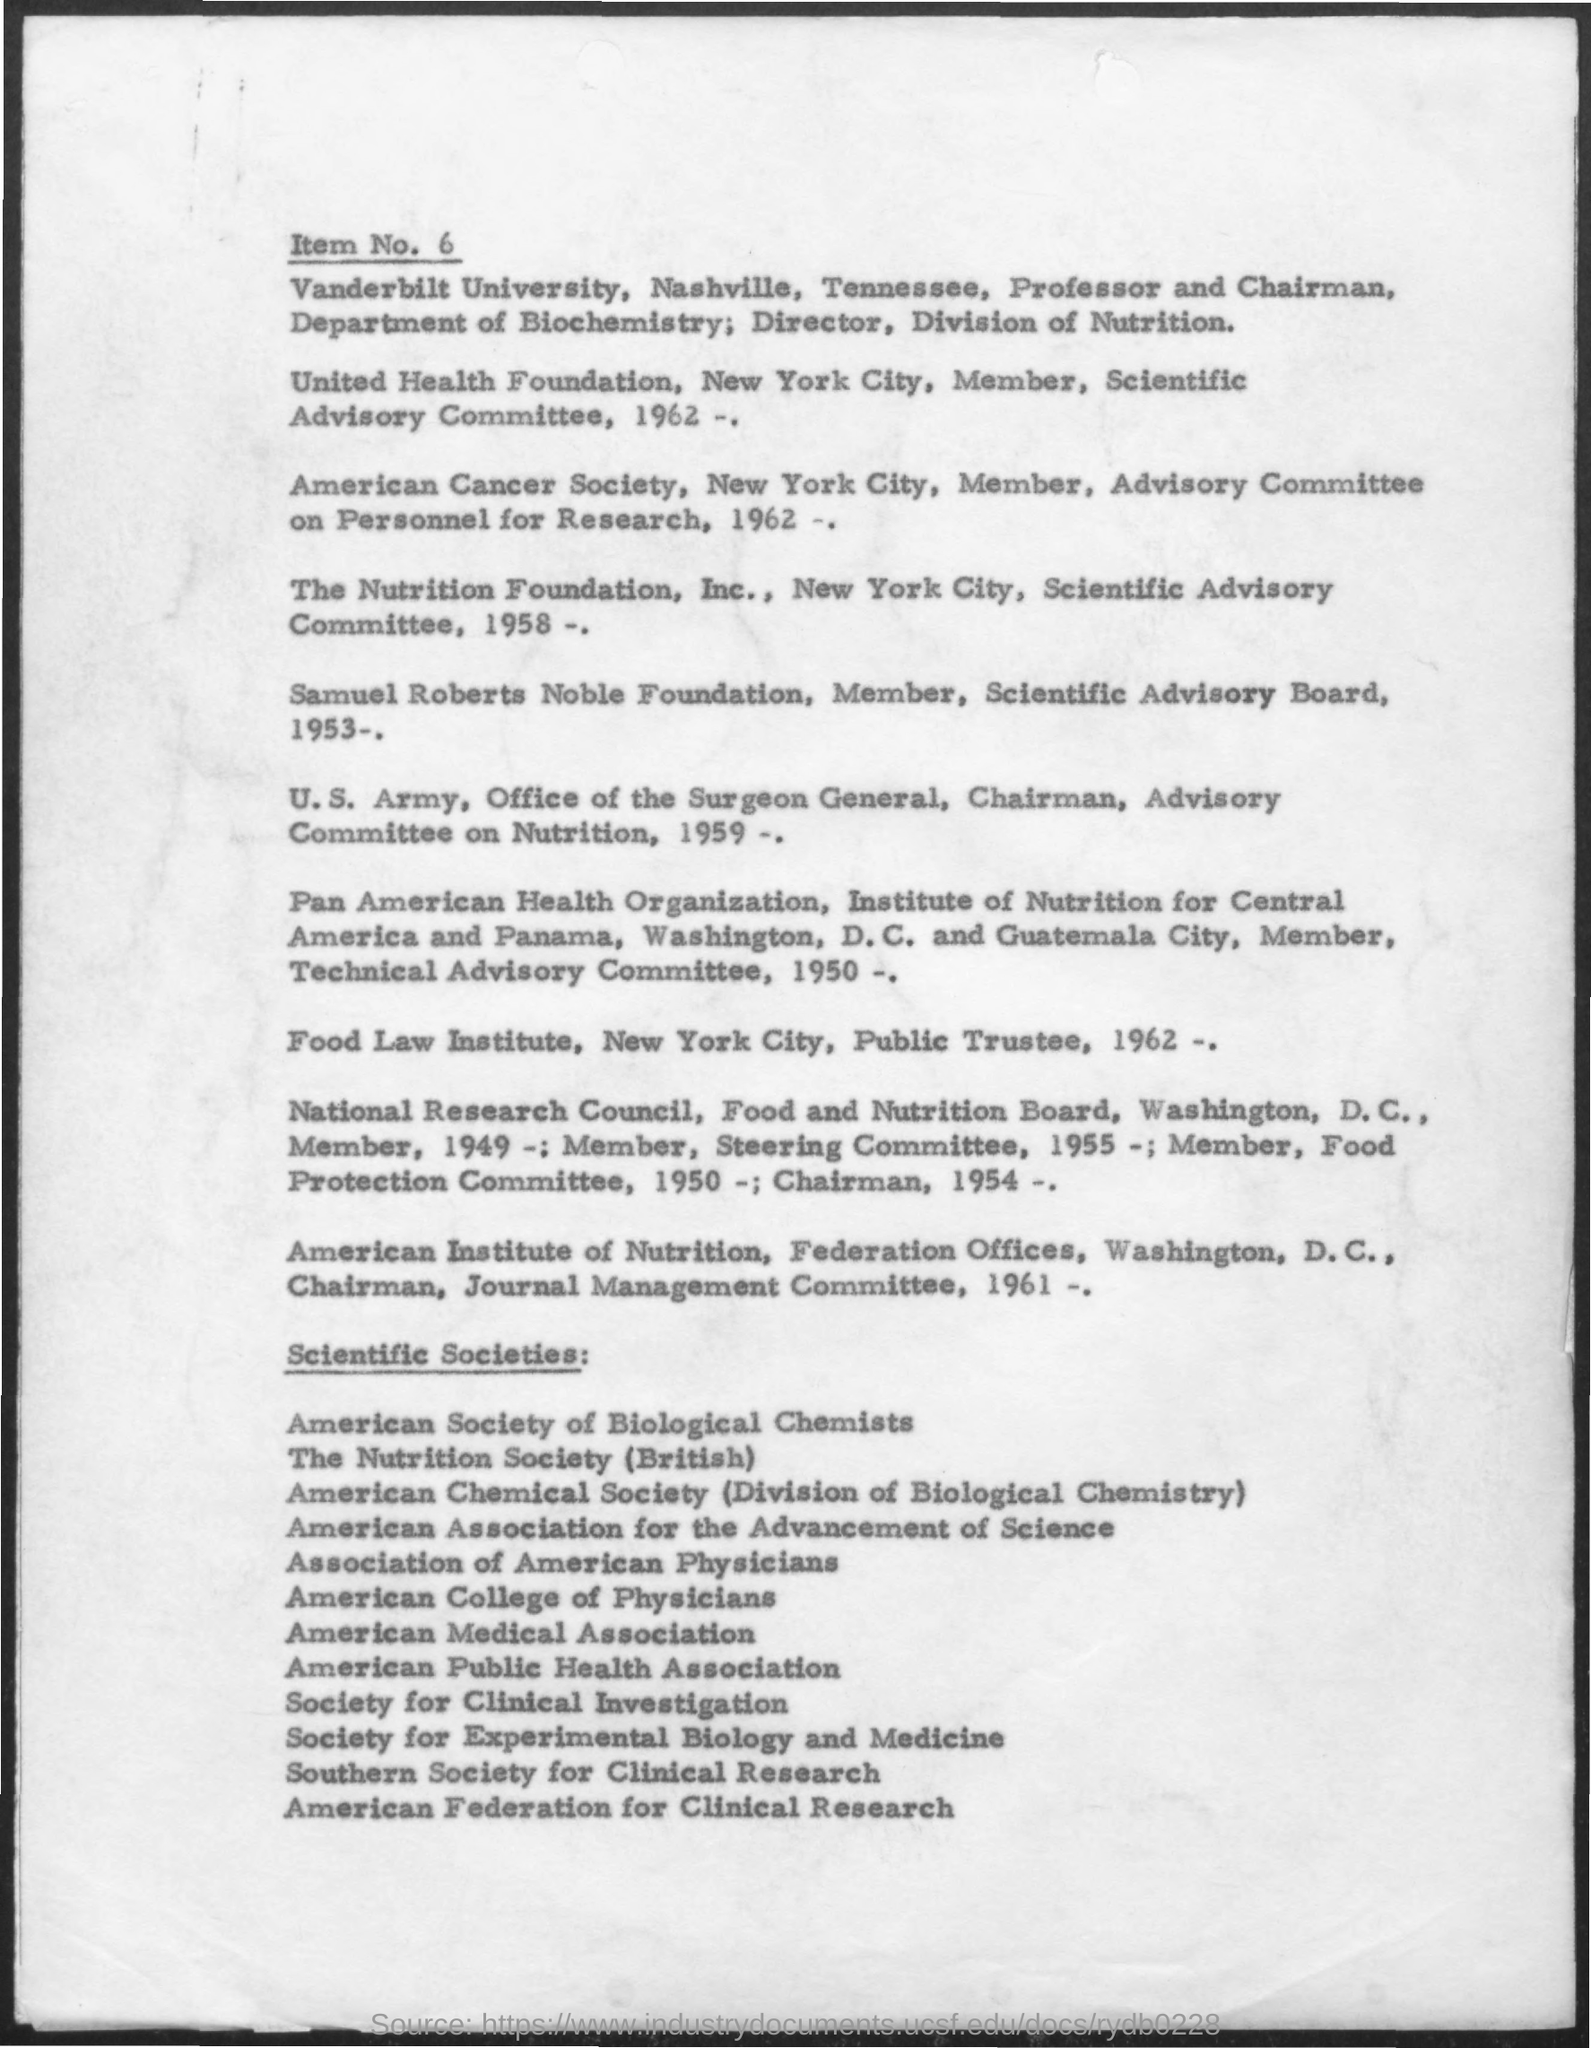What is the Item number?
Offer a terse response. 6. Food Law Institute was established in which year?
Your answer should be compact. 1962. The Nutrition Foundation, Inc. was established in which year?
Make the answer very short. 1958. 